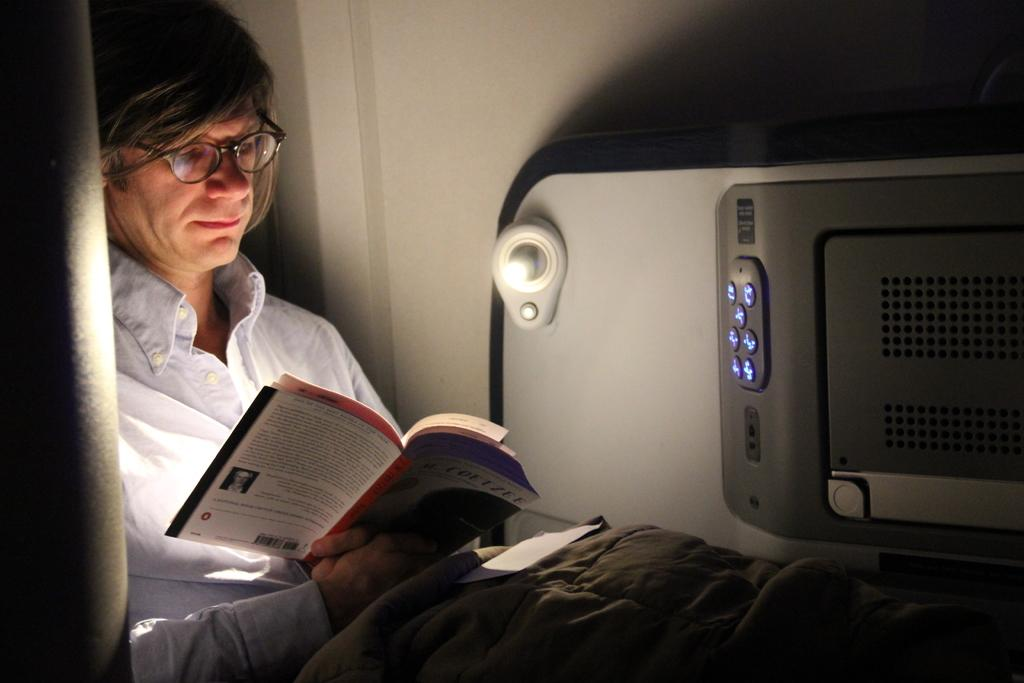What is the person in the image doing? The person is sitting in the image. What is the person holding? The person is holding a book. What is on the blanket in the image? There is a paper on the blanket. What can be seen in the background of the image? There is a wall and an object in the background of the image. What type of peace system is being discussed in the image? There is no discussion of a peace system in the image; it simply shows a person sitting with a book and a paper on a blanket. 